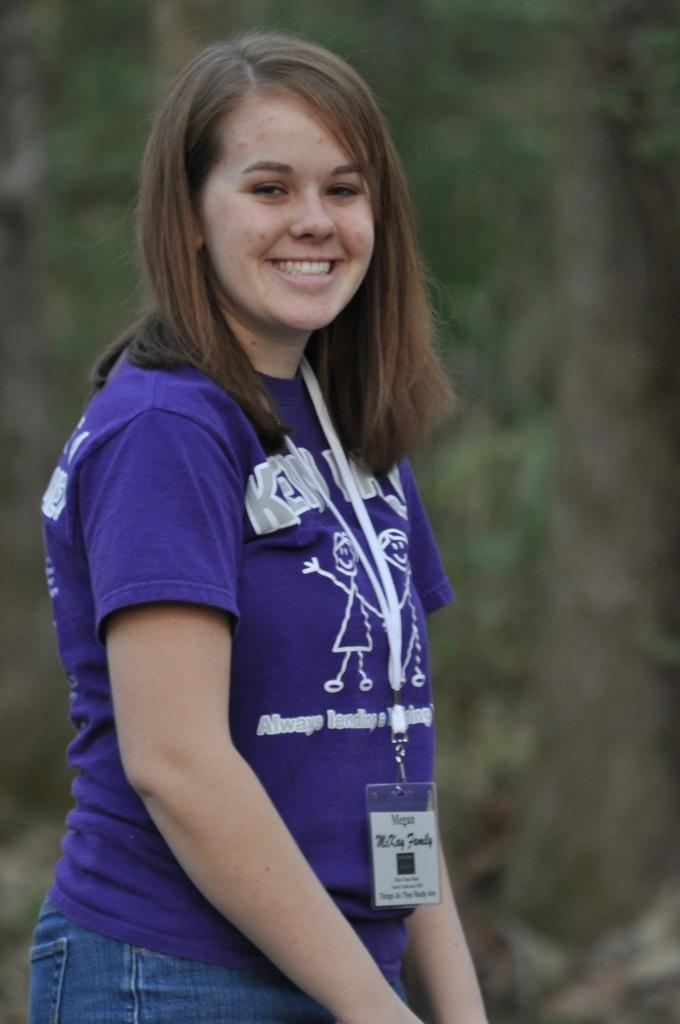Who is the main subject in the image? There is a lady in the center of the image. What is the lady doing in the image? The lady is standing and smiling. What can be seen in the background of the image? There are trees in the background of the image. What type of argument is taking place between the lady and the trees in the background? There is no argument present in the image; the lady is simply standing and smiling, and the trees are in the background. 